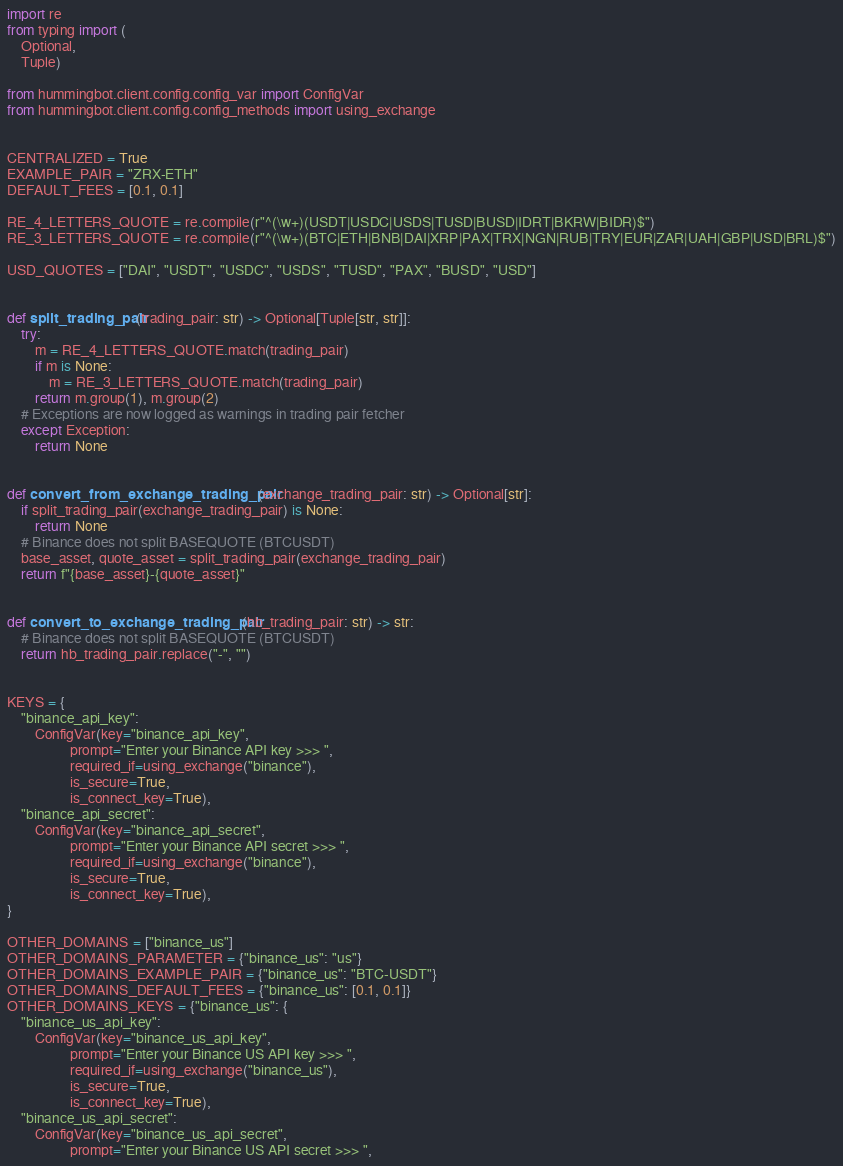<code> <loc_0><loc_0><loc_500><loc_500><_Python_>import re
from typing import (
    Optional,
    Tuple)

from hummingbot.client.config.config_var import ConfigVar
from hummingbot.client.config.config_methods import using_exchange


CENTRALIZED = True
EXAMPLE_PAIR = "ZRX-ETH"
DEFAULT_FEES = [0.1, 0.1]

RE_4_LETTERS_QUOTE = re.compile(r"^(\w+)(USDT|USDC|USDS|TUSD|BUSD|IDRT|BKRW|BIDR)$")
RE_3_LETTERS_QUOTE = re.compile(r"^(\w+)(BTC|ETH|BNB|DAI|XRP|PAX|TRX|NGN|RUB|TRY|EUR|ZAR|UAH|GBP|USD|BRL)$")

USD_QUOTES = ["DAI", "USDT", "USDC", "USDS", "TUSD", "PAX", "BUSD", "USD"]


def split_trading_pair(trading_pair: str) -> Optional[Tuple[str, str]]:
    try:
        m = RE_4_LETTERS_QUOTE.match(trading_pair)
        if m is None:
            m = RE_3_LETTERS_QUOTE.match(trading_pair)
        return m.group(1), m.group(2)
    # Exceptions are now logged as warnings in trading pair fetcher
    except Exception:
        return None


def convert_from_exchange_trading_pair(exchange_trading_pair: str) -> Optional[str]:
    if split_trading_pair(exchange_trading_pair) is None:
        return None
    # Binance does not split BASEQUOTE (BTCUSDT)
    base_asset, quote_asset = split_trading_pair(exchange_trading_pair)
    return f"{base_asset}-{quote_asset}"


def convert_to_exchange_trading_pair(hb_trading_pair: str) -> str:
    # Binance does not split BASEQUOTE (BTCUSDT)
    return hb_trading_pair.replace("-", "")


KEYS = {
    "binance_api_key":
        ConfigVar(key="binance_api_key",
                  prompt="Enter your Binance API key >>> ",
                  required_if=using_exchange("binance"),
                  is_secure=True,
                  is_connect_key=True),
    "binance_api_secret":
        ConfigVar(key="binance_api_secret",
                  prompt="Enter your Binance API secret >>> ",
                  required_if=using_exchange("binance"),
                  is_secure=True,
                  is_connect_key=True),
}

OTHER_DOMAINS = ["binance_us"]
OTHER_DOMAINS_PARAMETER = {"binance_us": "us"}
OTHER_DOMAINS_EXAMPLE_PAIR = {"binance_us": "BTC-USDT"}
OTHER_DOMAINS_DEFAULT_FEES = {"binance_us": [0.1, 0.1]}
OTHER_DOMAINS_KEYS = {"binance_us": {
    "binance_us_api_key":
        ConfigVar(key="binance_us_api_key",
                  prompt="Enter your Binance US API key >>> ",
                  required_if=using_exchange("binance_us"),
                  is_secure=True,
                  is_connect_key=True),
    "binance_us_api_secret":
        ConfigVar(key="binance_us_api_secret",
                  prompt="Enter your Binance US API secret >>> ",</code> 